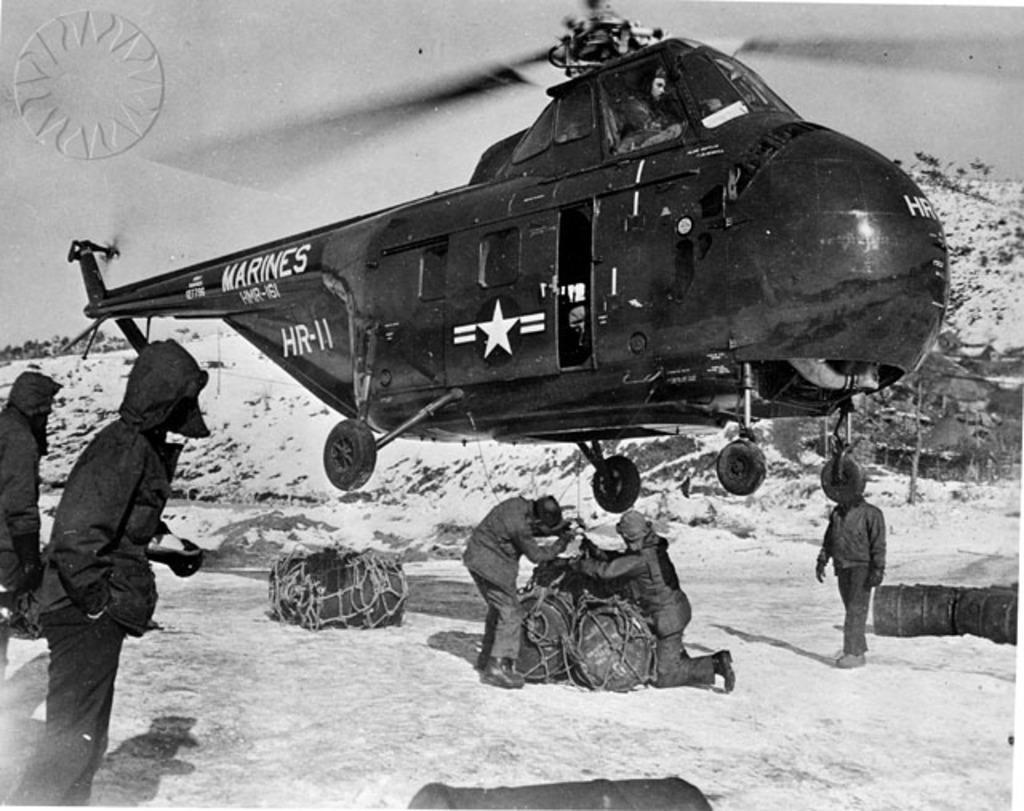How would you summarize this image in a sentence or two? In the center of the image a helicopter is there. At the bottom of the image we can see some persons and objects are there. In the middle of the image snow is there. At the top of the image sky is there. 